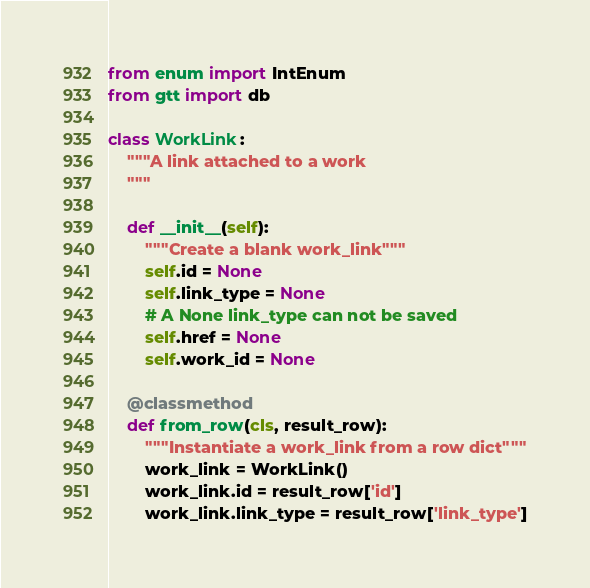Convert code to text. <code><loc_0><loc_0><loc_500><loc_500><_Python_>from enum import IntEnum
from gtt import db

class WorkLink:
    """A link attached to a work
    """

    def __init__(self):
        """Create a blank work_link"""
        self.id = None
        self.link_type = None
        # A None link_type can not be saved
        self.href = None
        self.work_id = None

    @classmethod
    def from_row(cls, result_row):
        """Instantiate a work_link from a row dict"""
        work_link = WorkLink()
        work_link.id = result_row['id']
        work_link.link_type = result_row['link_type']</code> 